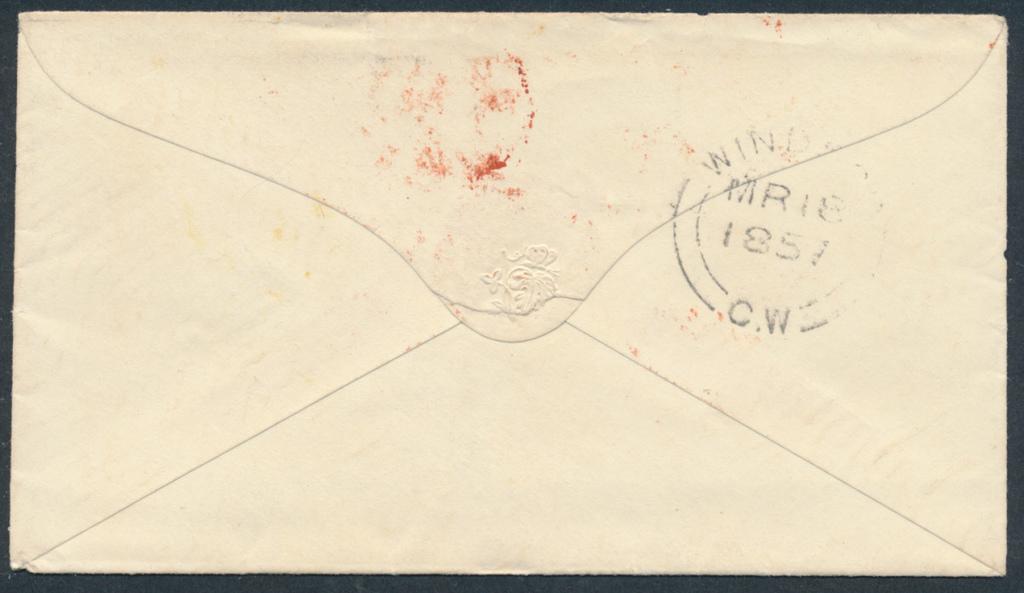Two letters on the bottom of the stamp?
Give a very brief answer. Cw. What year was this stamped?
Your answer should be very brief. 1851. 